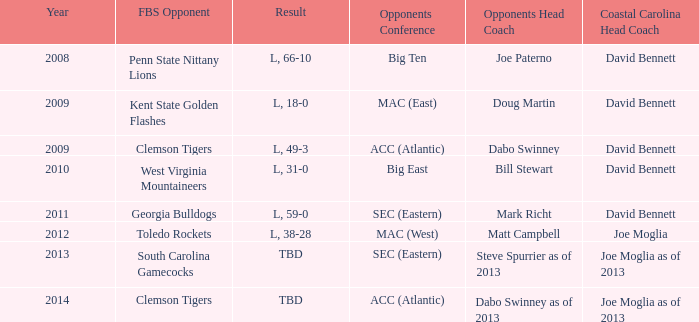What was the result when then opponents conference was Mac (east)? L, 18-0. 